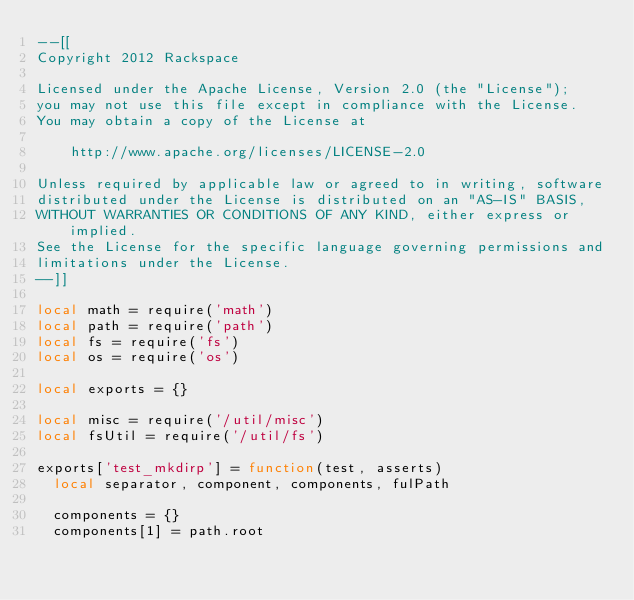<code> <loc_0><loc_0><loc_500><loc_500><_Lua_>--[[
Copyright 2012 Rackspace

Licensed under the Apache License, Version 2.0 (the "License");
you may not use this file except in compliance with the License.
You may obtain a copy of the License at

    http://www.apache.org/licenses/LICENSE-2.0

Unless required by applicable law or agreed to in writing, software
distributed under the License is distributed on an "AS-IS" BASIS,
WITHOUT WARRANTIES OR CONDITIONS OF ANY KIND, either express or implied.
See the License for the specific language governing permissions and
limitations under the License.
--]]

local math = require('math')
local path = require('path')
local fs = require('fs')
local os = require('os')

local exports = {}

local misc = require('/util/misc')
local fsUtil = require('/util/fs')

exports['test_mkdirp'] = function(test, asserts)
  local separator, component, components, fulPath

  components = {}
  components[1] = path.root
</code> 